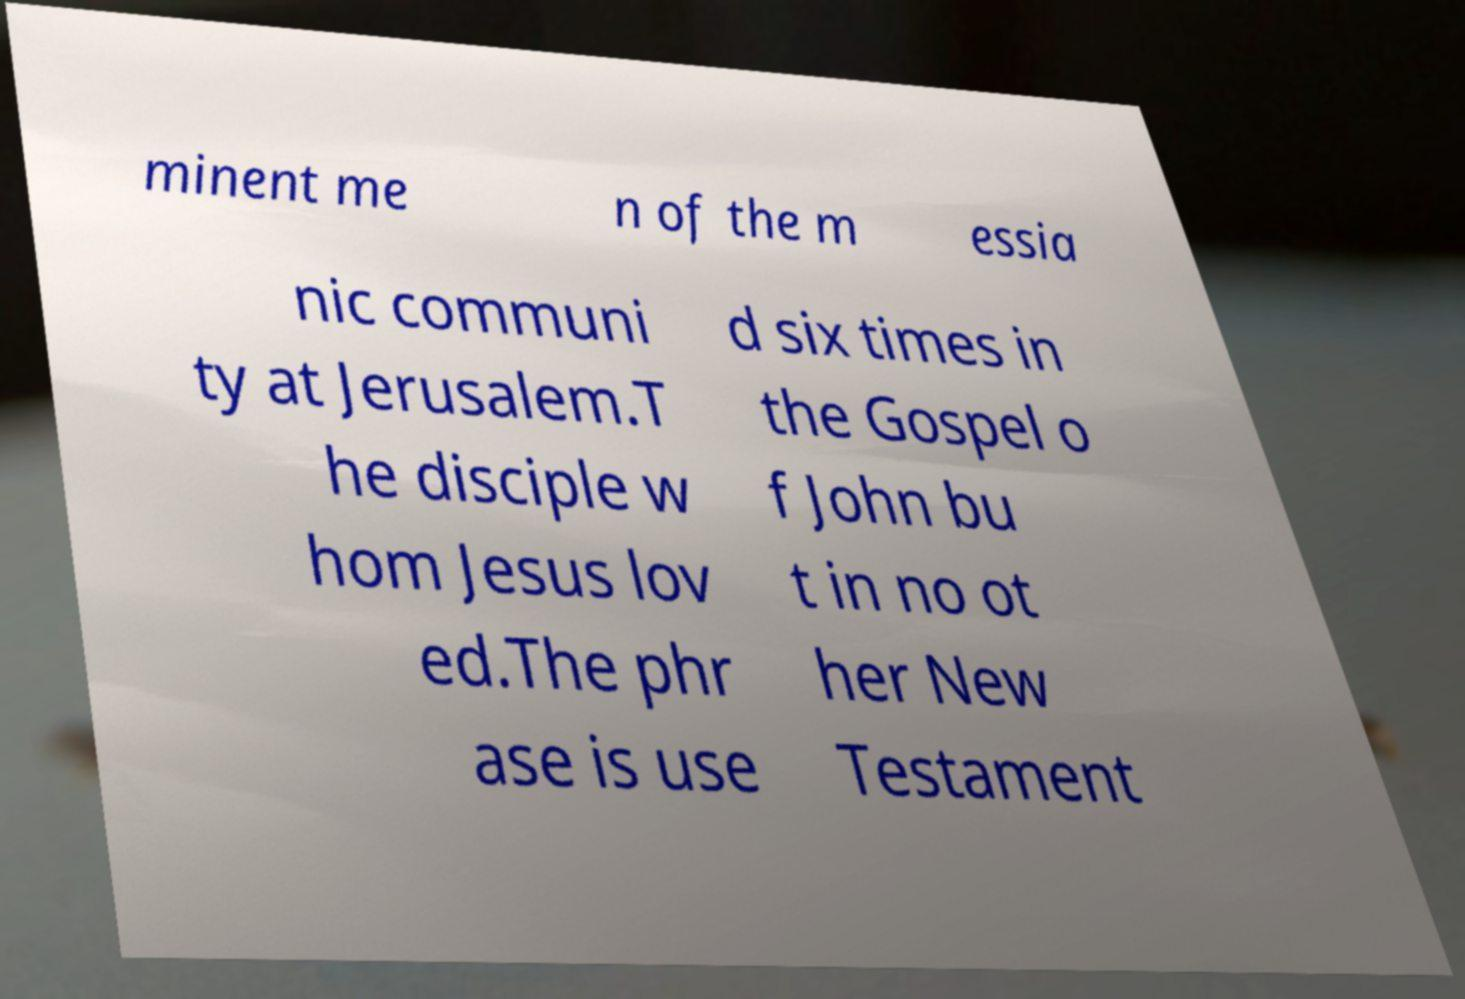Can you read and provide the text displayed in the image?This photo seems to have some interesting text. Can you extract and type it out for me? minent me n of the m essia nic communi ty at Jerusalem.T he disciple w hom Jesus lov ed.The phr ase is use d six times in the Gospel o f John bu t in no ot her New Testament 